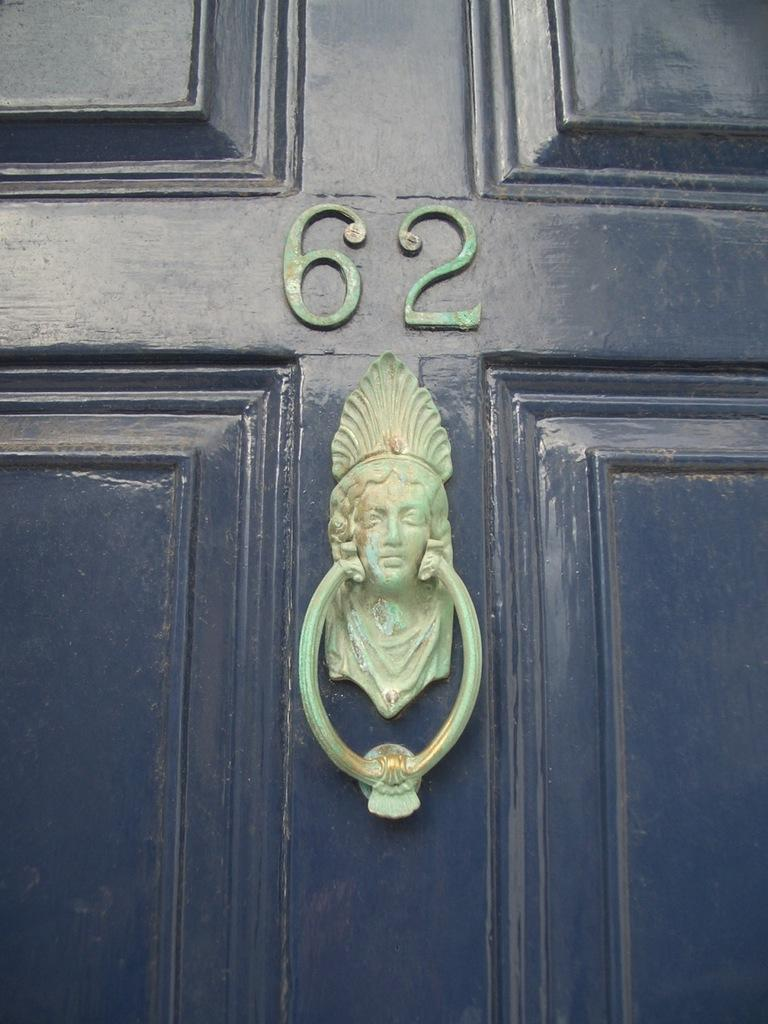What can be seen in the foreground of the image? There is a knocker on a door in the foreground of the image. What numbers or digits are visible in the image? There are two digits visible in the image. What type of art or decoration is present in the image? There is a sculpture in the image. What type of sleet can be seen falling from the sky in the image? There is no sleet visible in the image; it does not mention any weather conditions. How many women are present in the image? There is no mention of any women in the image; the facts provided focus on the door, digits, and sculpture. 